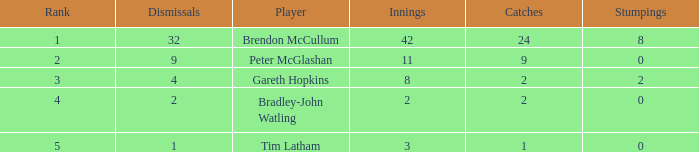What is the number of stumpings tim latham achieved? 0.0. 